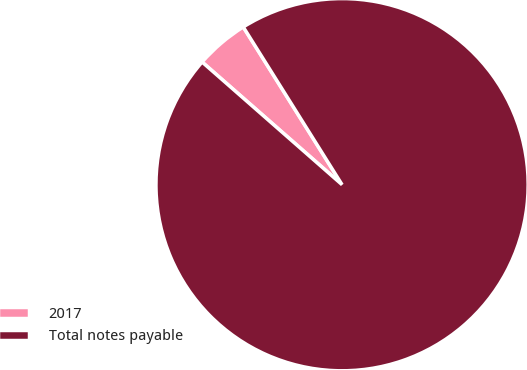<chart> <loc_0><loc_0><loc_500><loc_500><pie_chart><fcel>2017<fcel>Total notes payable<nl><fcel>4.64%<fcel>95.36%<nl></chart> 